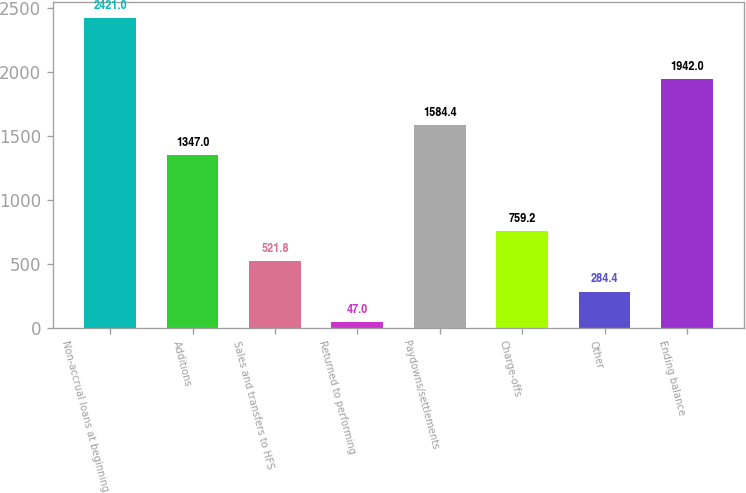Convert chart to OTSL. <chart><loc_0><loc_0><loc_500><loc_500><bar_chart><fcel>Non-accrual loans at beginning<fcel>Additions<fcel>Sales and transfers to HFS<fcel>Returned to performing<fcel>Paydowns/settlements<fcel>Charge-offs<fcel>Other<fcel>Ending balance<nl><fcel>2421<fcel>1347<fcel>521.8<fcel>47<fcel>1584.4<fcel>759.2<fcel>284.4<fcel>1942<nl></chart> 